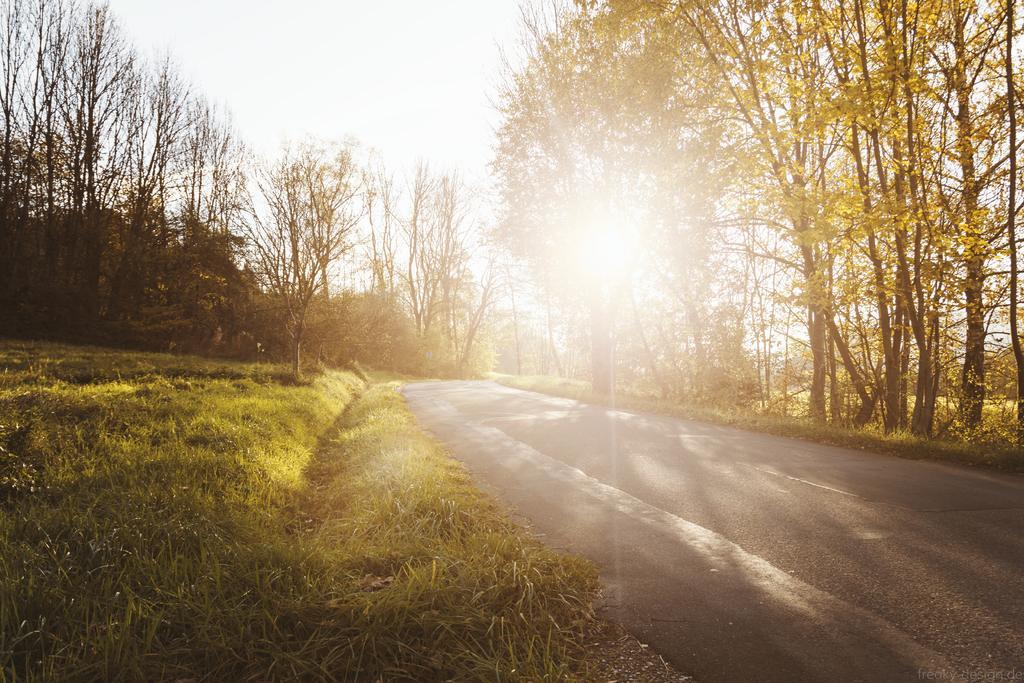Please provide a concise description of this image. In this picture, we can see the road, ground covered with grass, plants and we can see some trees and the sky. 